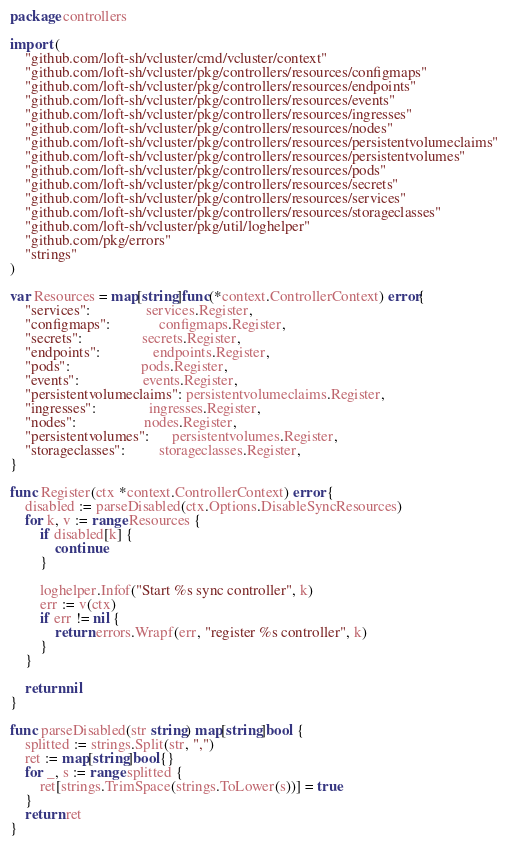Convert code to text. <code><loc_0><loc_0><loc_500><loc_500><_Go_>package controllers

import (
	"github.com/loft-sh/vcluster/cmd/vcluster/context"
	"github.com/loft-sh/vcluster/pkg/controllers/resources/configmaps"
	"github.com/loft-sh/vcluster/pkg/controllers/resources/endpoints"
	"github.com/loft-sh/vcluster/pkg/controllers/resources/events"
	"github.com/loft-sh/vcluster/pkg/controllers/resources/ingresses"
	"github.com/loft-sh/vcluster/pkg/controllers/resources/nodes"
	"github.com/loft-sh/vcluster/pkg/controllers/resources/persistentvolumeclaims"
	"github.com/loft-sh/vcluster/pkg/controllers/resources/persistentvolumes"
	"github.com/loft-sh/vcluster/pkg/controllers/resources/pods"
	"github.com/loft-sh/vcluster/pkg/controllers/resources/secrets"
	"github.com/loft-sh/vcluster/pkg/controllers/resources/services"
	"github.com/loft-sh/vcluster/pkg/controllers/resources/storageclasses"
	"github.com/loft-sh/vcluster/pkg/util/loghelper"
	"github.com/pkg/errors"
	"strings"
)

var Resources = map[string]func(*context.ControllerContext) error{
	"services":               services.Register,
	"configmaps":             configmaps.Register,
	"secrets":                secrets.Register,
	"endpoints":              endpoints.Register,
	"pods":                   pods.Register,
	"events":                 events.Register,
	"persistentvolumeclaims": persistentvolumeclaims.Register,
	"ingresses":              ingresses.Register,
	"nodes":                  nodes.Register,
	"persistentvolumes":      persistentvolumes.Register,
	"storageclasses":         storageclasses.Register,
}

func Register(ctx *context.ControllerContext) error {
	disabled := parseDisabled(ctx.Options.DisableSyncResources)
	for k, v := range Resources {
		if disabled[k] {
			continue
		}

		loghelper.Infof("Start %s sync controller", k)
		err := v(ctx)
		if err != nil {
			return errors.Wrapf(err, "register %s controller", k)
		}
	}

	return nil
}

func parseDisabled(str string) map[string]bool {
	splitted := strings.Split(str, ",")
	ret := map[string]bool{}
	for _, s := range splitted {
		ret[strings.TrimSpace(strings.ToLower(s))] = true
	}
	return ret
}
</code> 